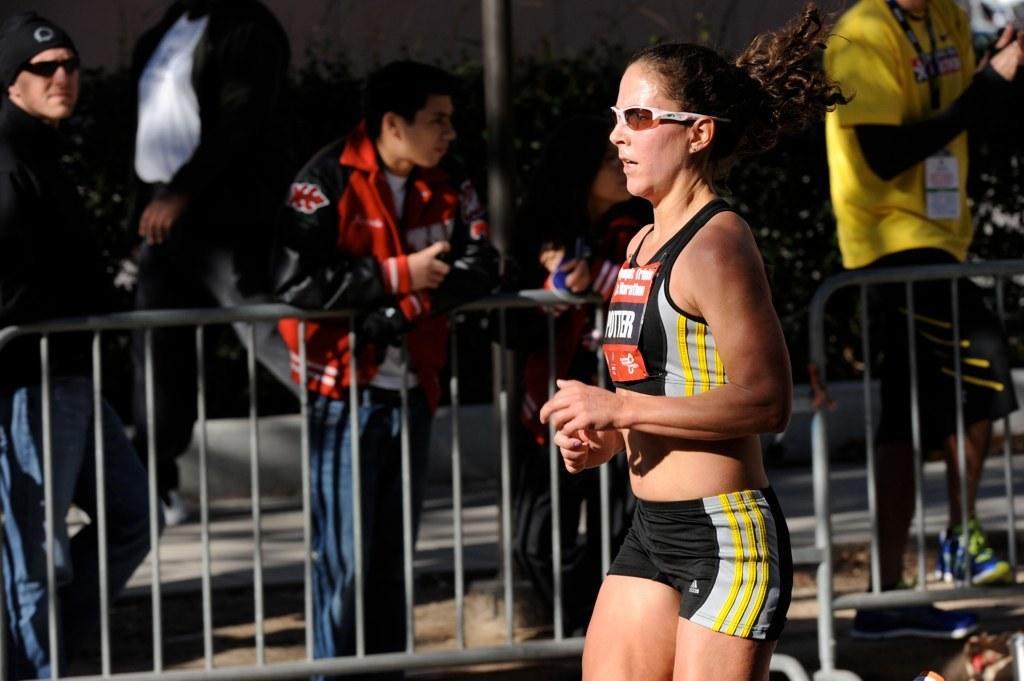In one or two sentences, can you explain what this image depicts? In this image in the front there is a woman. In the background there is a fence and behind the fence there are persons standing, there are plants and there is a wall and there is a pole. 